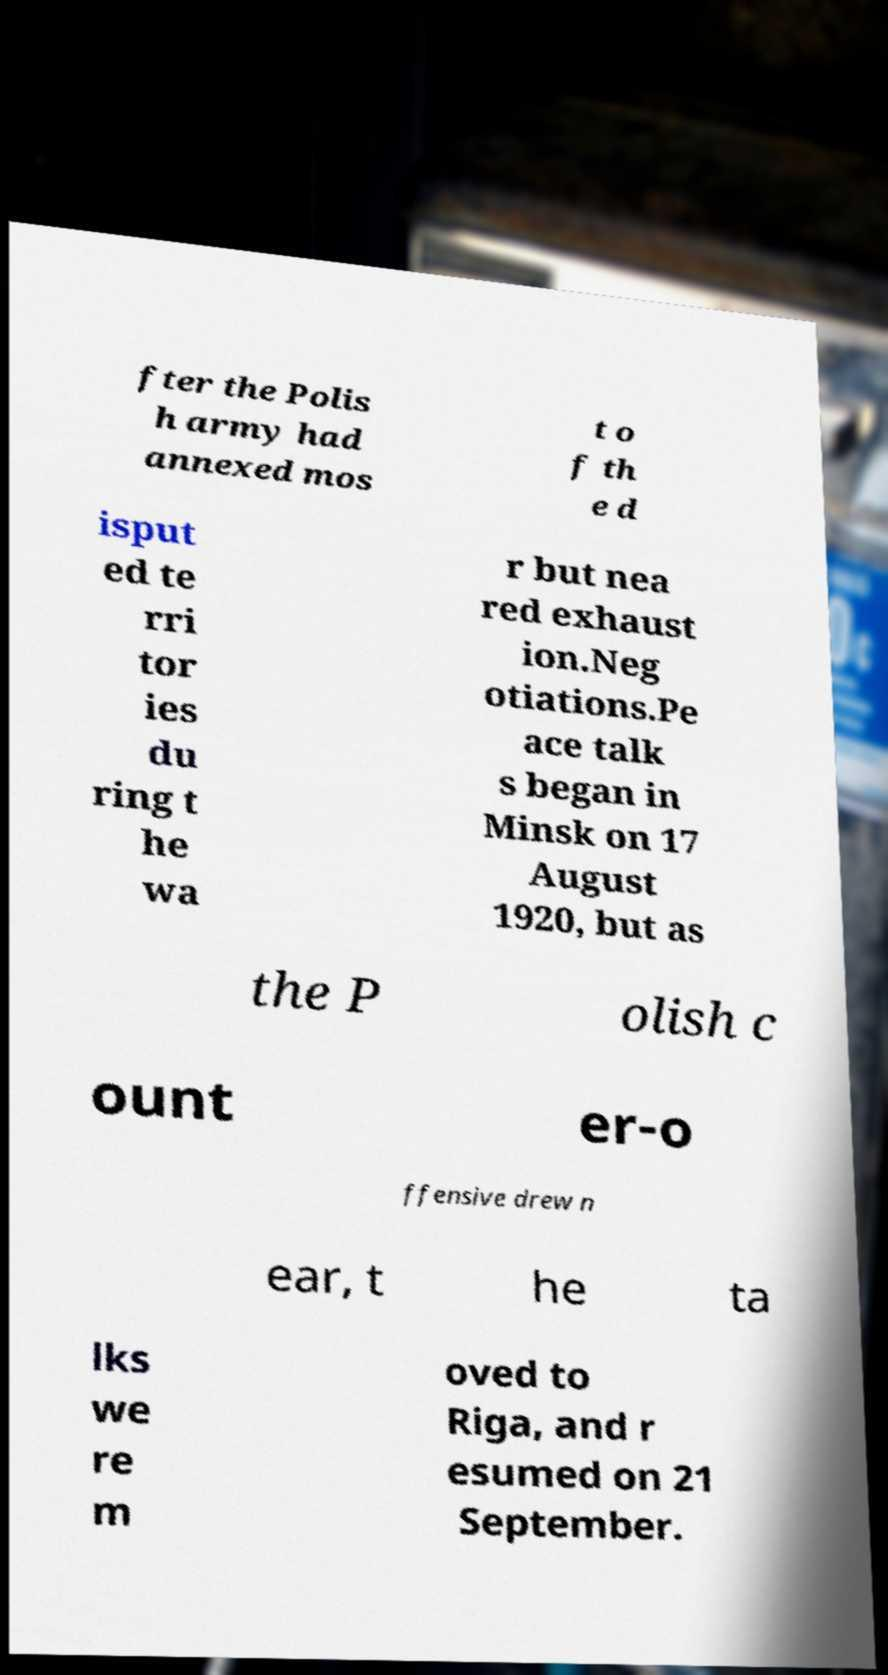Can you read and provide the text displayed in the image?This photo seems to have some interesting text. Can you extract and type it out for me? fter the Polis h army had annexed mos t o f th e d isput ed te rri tor ies du ring t he wa r but nea red exhaust ion.Neg otiations.Pe ace talk s began in Minsk on 17 August 1920, but as the P olish c ount er-o ffensive drew n ear, t he ta lks we re m oved to Riga, and r esumed on 21 September. 